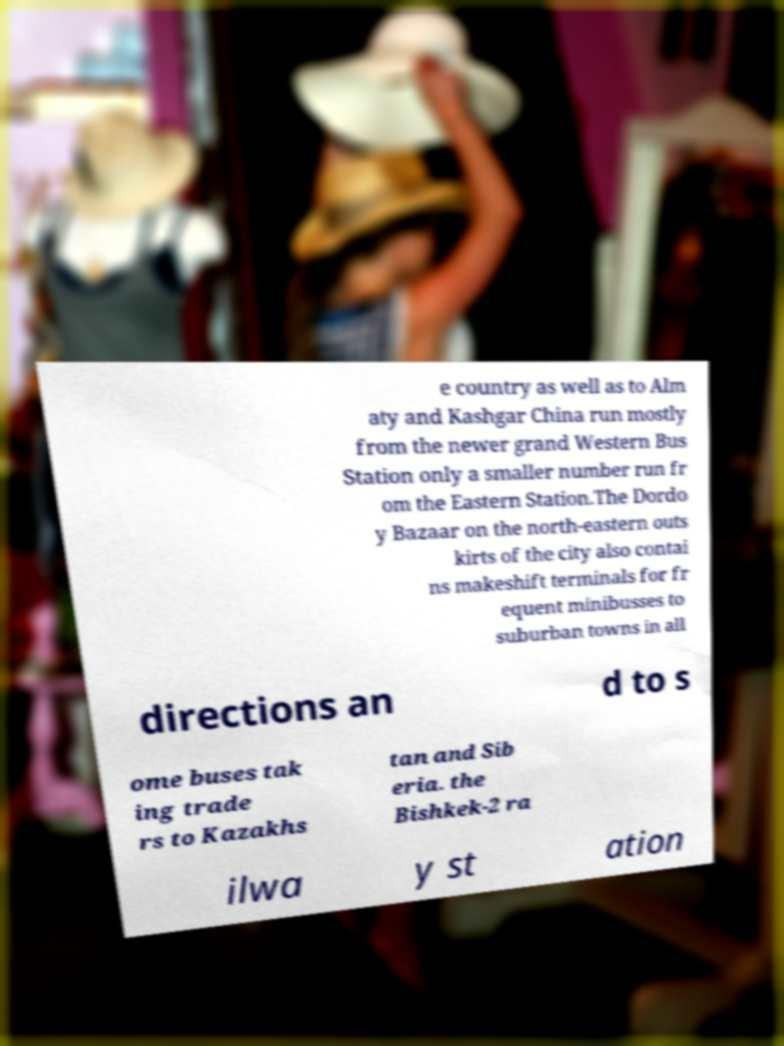Can you accurately transcribe the text from the provided image for me? e country as well as to Alm aty and Kashgar China run mostly from the newer grand Western Bus Station only a smaller number run fr om the Eastern Station.The Dordo y Bazaar on the north-eastern outs kirts of the city also contai ns makeshift terminals for fr equent minibusses to suburban towns in all directions an d to s ome buses tak ing trade rs to Kazakhs tan and Sib eria. the Bishkek-2 ra ilwa y st ation 